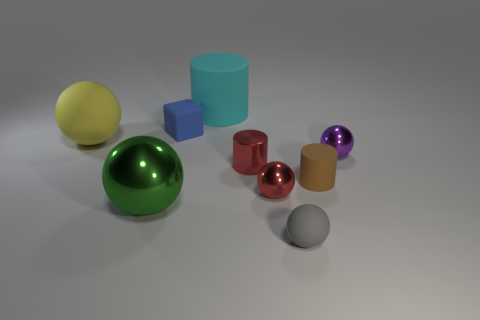Subtract 2 spheres. How many spheres are left? 3 Subtract all yellow balls. How many balls are left? 4 Subtract all gray spheres. How many spheres are left? 4 Subtract all blue balls. Subtract all green cylinders. How many balls are left? 5 Add 1 big rubber balls. How many objects exist? 10 Subtract all balls. How many objects are left? 4 Add 1 gray metal cylinders. How many gray metal cylinders exist? 1 Subtract 0 cyan balls. How many objects are left? 9 Subtract all big red shiny blocks. Subtract all small cubes. How many objects are left? 8 Add 8 red metallic cylinders. How many red metallic cylinders are left? 9 